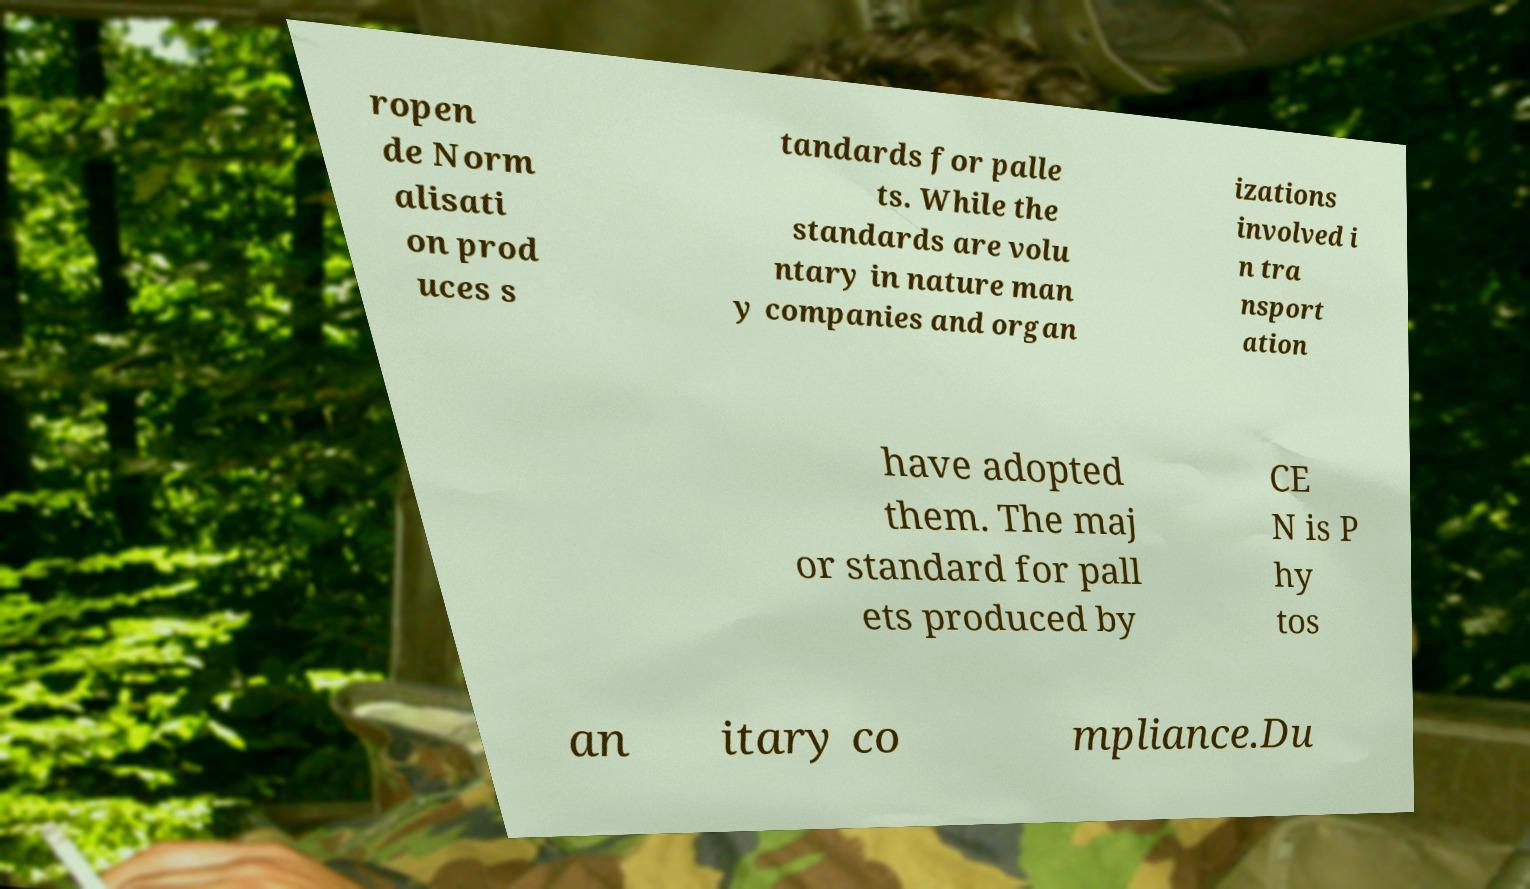There's text embedded in this image that I need extracted. Can you transcribe it verbatim? ropen de Norm alisati on prod uces s tandards for palle ts. While the standards are volu ntary in nature man y companies and organ izations involved i n tra nsport ation have adopted them. The maj or standard for pall ets produced by CE N is P hy tos an itary co mpliance.Du 